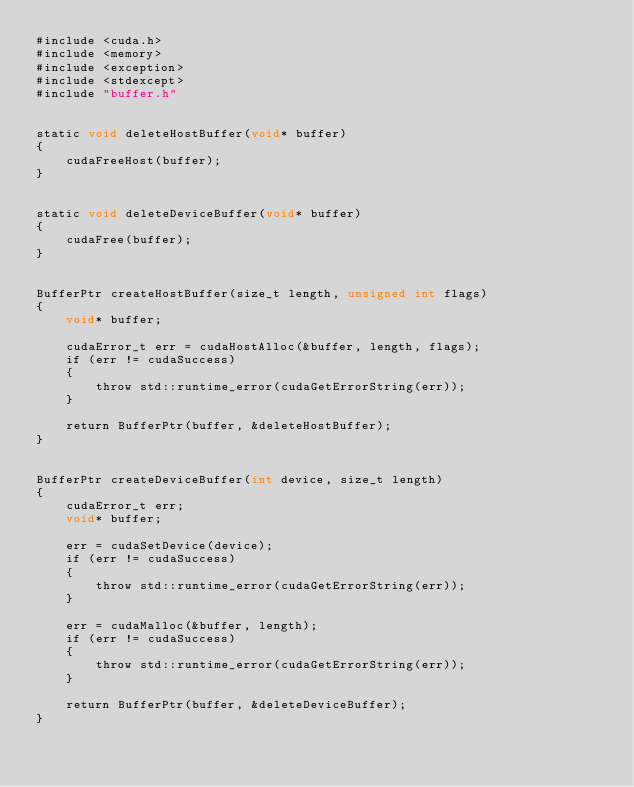<code> <loc_0><loc_0><loc_500><loc_500><_Cuda_>#include <cuda.h>
#include <memory>
#include <exception>
#include <stdexcept>
#include "buffer.h"


static void deleteHostBuffer(void* buffer)
{
    cudaFreeHost(buffer);
}


static void deleteDeviceBuffer(void* buffer)
{
    cudaFree(buffer);
}


BufferPtr createHostBuffer(size_t length, unsigned int flags)
{
    void* buffer;

    cudaError_t err = cudaHostAlloc(&buffer, length, flags);
    if (err != cudaSuccess)
    {
        throw std::runtime_error(cudaGetErrorString(err));
    }

    return BufferPtr(buffer, &deleteHostBuffer);
}


BufferPtr createDeviceBuffer(int device, size_t length)
{
    cudaError_t err;
    void* buffer;

    err = cudaSetDevice(device);
    if (err != cudaSuccess)
    {
        throw std::runtime_error(cudaGetErrorString(err));
    }

    err = cudaMalloc(&buffer, length);
    if (err != cudaSuccess)
    {
        throw std::runtime_error(cudaGetErrorString(err));
    }

    return BufferPtr(buffer, &deleteDeviceBuffer);
}
</code> 